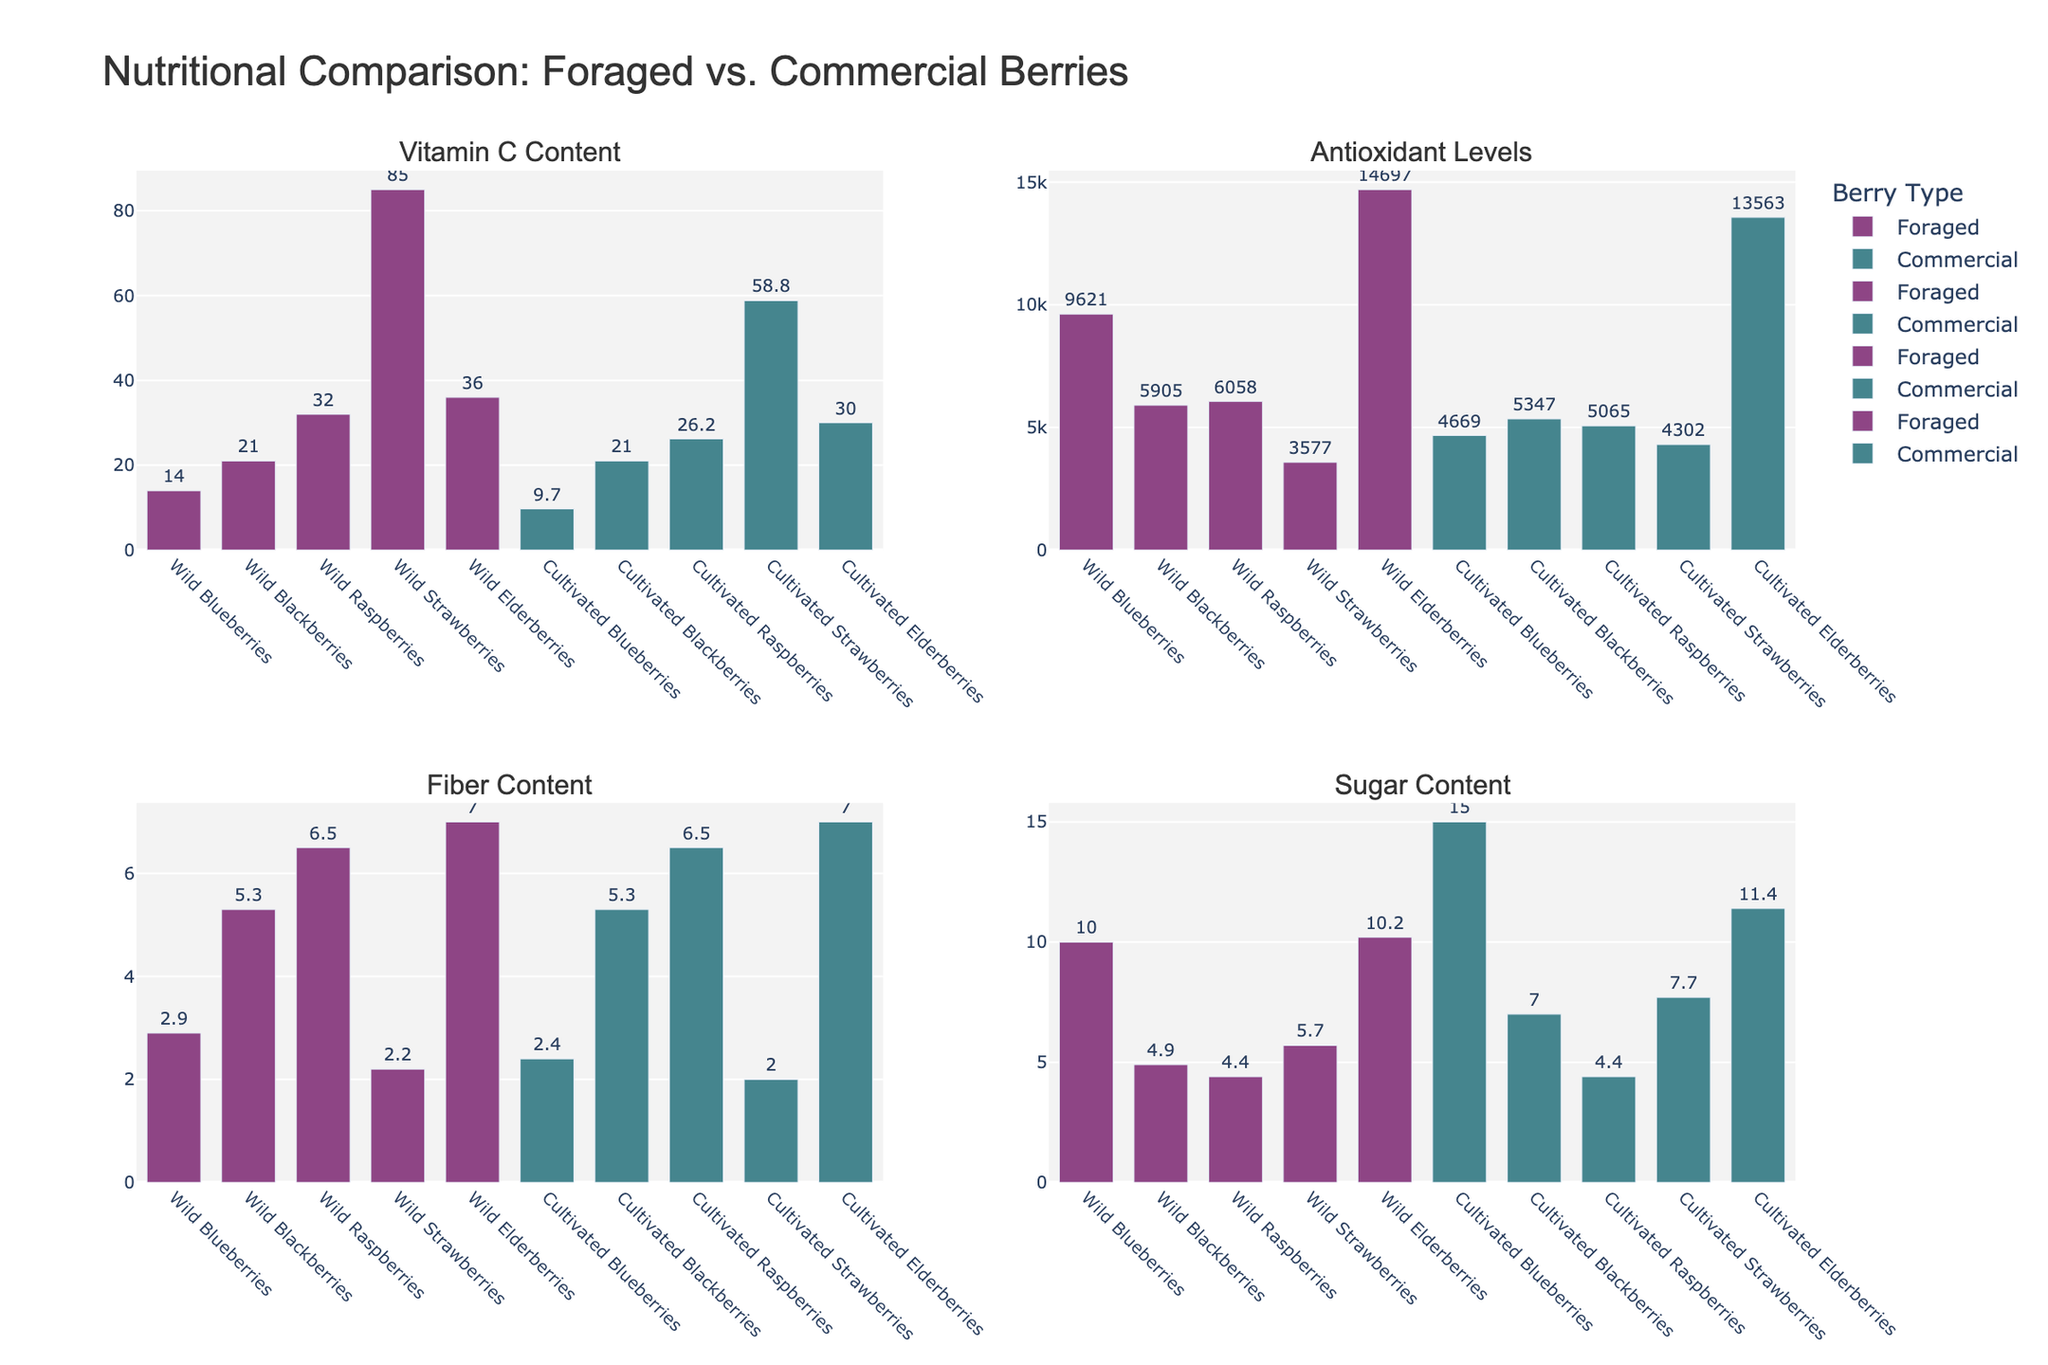What is the title of the figure? The title of the figure is placed at the top of the visualization. It usually summarizes the overall purpose or main comparison being made in the chart. In this case, it reads "Nutritional Comparison: Foraged vs. Commercial Berries".
Answer: Nutritional Comparison: Foraged vs. Commercial Berries Which type of berry has the highest Vitamin C content? To find the highest Vitamin C content, look at the "Vitamin C Content" subplot and identify the tallest bar. Wild Strawberries have the tallest bar, denoting the highest Vitamin C content.
Answer: Wild Strawberries Compare the antioxidant levels of wild and cultivated elderberries. Which one is higher? In the "Antioxidant Levels" subplot, locate the bars for wild and cultivated elderberries and compare their heights. The bar for wild elderberries is higher, indicating they have higher antioxidant levels.
Answer: Wild Elderberries What is the fiber content difference between wild and cultivated raspberries? To determine the difference in fiber content between wild and cultivated raspberries, find the corresponding bars in the "Fiber Content" subplot. Both bars have the same value of 6.5 g/100g. The difference is calculated by subtracting these values, which results in a difference of 0.
Answer: 0 Which type of blackberry has lower sugar content? Look at the "Sugar Content" subplot and find the bars for wild and cultivated blackberries. The bar representing wild blackberries is lower than the one for cultivated blackberries, meaning it has lower sugar content.
Answer: Wild Blackberries How do the vitamin C contents of wild and cultivated strawberries compare? Locate the bars for wild and cultivated strawberries in the "Vitamin C Content" subplot. Wild strawberries have a higher bar, indicating a greater Vitamin C content (85 mg/100g vs. 58.8 mg/100g).
Answer: Wild Strawberries have more Vitamin C What’s the combined antioxidant level of all foraged berries? To get the combined antioxidant level, add the antioxidant values from the "Antioxidant Levels" subplot for all foraged berries: 9621 (Wild Blueberries), 5905 (Wild Blackberries), 6058 (Wild Raspberries), 3577 (Wild Strawberries), and 14697 (Wild Elderberries). Sum = 9621 + 5905 + 6058 + 3577 + 14697 = 39858.
Answer: 39858 Which foraged berries have the same fiber content? Check the "Fiber Content" subplot and look for foraged berries with bars that reach the same height. Wild Blackberries and Wild Elderberries both have a fiber content of 7 g/100g.
Answer: Wild Blackberries and Wild Elderberries Is there a significant difference in sugar content between wild and cultivated blueberries? In the "Sugar Content" subplot, compare the bars for wild and cultivated blueberries. Wild blueberries have a sugar content of 10 g/100g, whereas cultivated blueberries have 15 g/100g. The difference is 15 - 10 = 5 g/100g, which is a noticeable difference.
Answer: Yes, there is a significant difference (5 g/100g) What’s the total number of different berries compared in the chart? By looking at any subplot, count the distinct berry types listed along the x-axis. There are Wild Blueberries, Cultivated Blueberries, Wild Blackberries, Cultivated Blackberries, Wild Raspberries, Cultivated Raspberries, Wild Strawberries, Cultivated Strawberries, Wild Elderberries, and Cultivated Elderberries. This adds up to a total of 10 different berries compared in the chart.
Answer: 10 